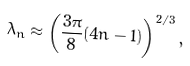Convert formula to latex. <formula><loc_0><loc_0><loc_500><loc_500>\lambda _ { n } \approx \left ( \frac { 3 \pi } { 8 } ( 4 n - 1 ) \right ) ^ { 2 / 3 } ,</formula> 